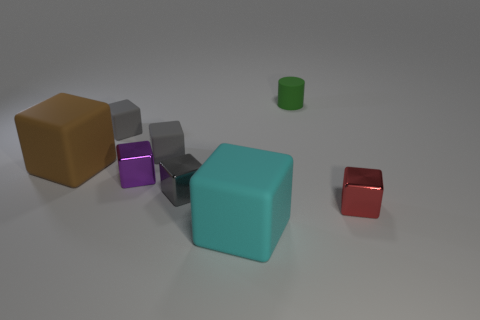Subtract all yellow cylinders. How many gray blocks are left? 3 Subtract all cyan blocks. How many blocks are left? 6 Subtract all small purple metal blocks. How many blocks are left? 6 Subtract all brown cylinders. Subtract all red blocks. How many cylinders are left? 1 Add 1 big cyan objects. How many objects exist? 9 Subtract all cylinders. How many objects are left? 7 Add 2 gray rubber blocks. How many gray rubber blocks exist? 4 Subtract 1 brown blocks. How many objects are left? 7 Subtract all cyan cubes. Subtract all purple shiny blocks. How many objects are left? 6 Add 1 cubes. How many cubes are left? 8 